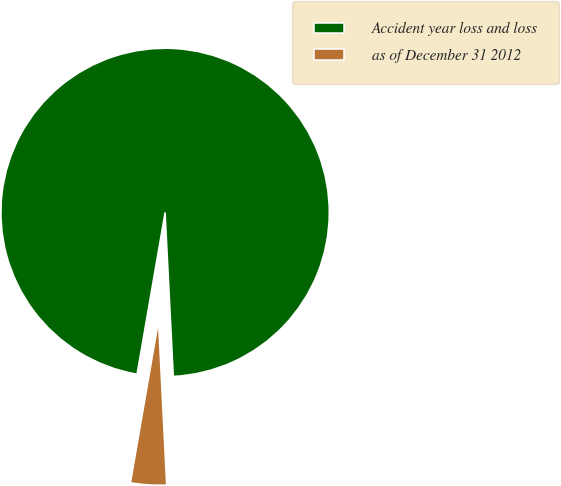Convert chart. <chart><loc_0><loc_0><loc_500><loc_500><pie_chart><fcel>Accident year loss and loss<fcel>as of December 31 2012<nl><fcel>96.47%<fcel>3.53%<nl></chart> 